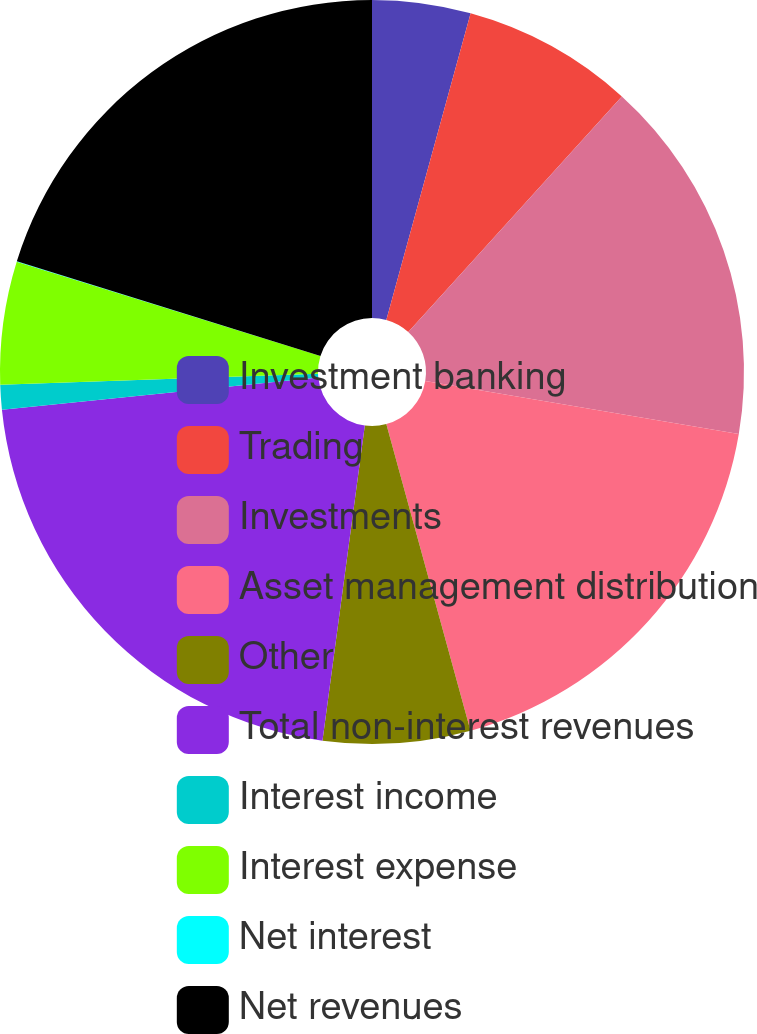Convert chart. <chart><loc_0><loc_0><loc_500><loc_500><pie_chart><fcel>Investment banking<fcel>Trading<fcel>Investments<fcel>Asset management distribution<fcel>Other<fcel>Total non-interest revenues<fcel>Interest income<fcel>Interest expense<fcel>Net interest<fcel>Net revenues<nl><fcel>4.27%<fcel>7.45%<fcel>15.94%<fcel>18.07%<fcel>6.39%<fcel>21.25%<fcel>1.08%<fcel>5.33%<fcel>0.02%<fcel>20.19%<nl></chart> 